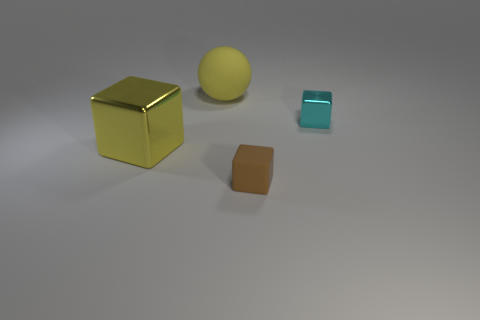Subtract all small cubes. How many cubes are left? 1 Subtract all balls. How many objects are left? 3 Add 1 large yellow rubber cylinders. How many objects exist? 5 Subtract all small blue matte things. Subtract all rubber things. How many objects are left? 2 Add 2 yellow blocks. How many yellow blocks are left? 3 Add 1 tiny brown things. How many tiny brown things exist? 2 Subtract 0 blue blocks. How many objects are left? 4 Subtract all red spheres. Subtract all green cylinders. How many spheres are left? 1 